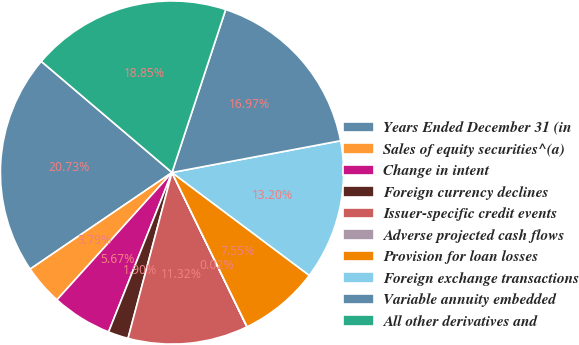Convert chart. <chart><loc_0><loc_0><loc_500><loc_500><pie_chart><fcel>Years Ended December 31 (in<fcel>Sales of equity securities^(a)<fcel>Change in intent<fcel>Foreign currency declines<fcel>Issuer-specific credit events<fcel>Adverse projected cash flows<fcel>Provision for loan losses<fcel>Foreign exchange transactions<fcel>Variable annuity embedded<fcel>All other derivatives and<nl><fcel>20.73%<fcel>3.79%<fcel>5.67%<fcel>1.9%<fcel>11.32%<fcel>0.02%<fcel>7.55%<fcel>13.2%<fcel>16.97%<fcel>18.85%<nl></chart> 